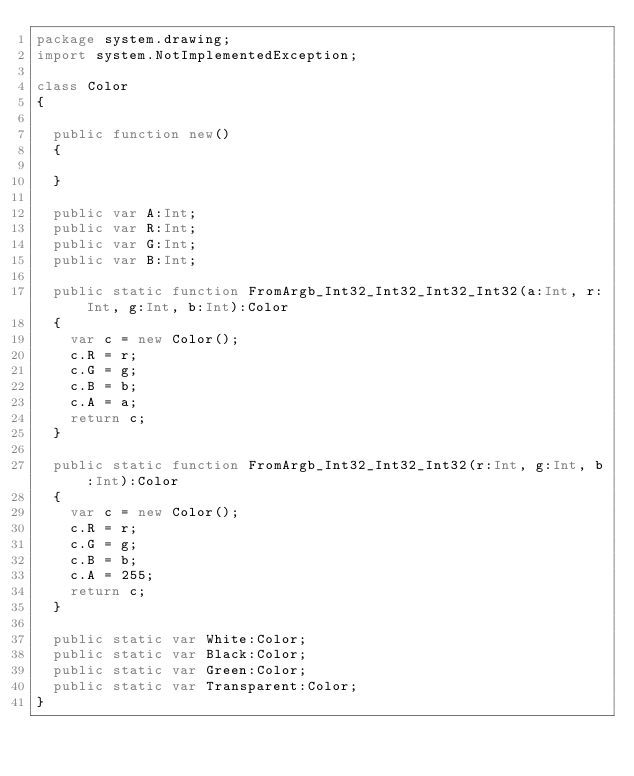<code> <loc_0><loc_0><loc_500><loc_500><_Haxe_>package system.drawing;
import system.NotImplementedException;

class Color
{

	public function new() 
	{
		
	}
	
	public var A:Int;
	public var R:Int;
	public var G:Int;
	public var B:Int;
	
	public static function FromArgb_Int32_Int32_Int32_Int32(a:Int, r:Int, g:Int, b:Int):Color
	{
		var c = new Color();
		c.R = r;
		c.G = g;
		c.B = b;
		c.A = a;
		return c;
	}
	
	public static function FromArgb_Int32_Int32_Int32(r:Int, g:Int, b:Int):Color
	{
		var c = new Color();
		c.R = r;
		c.G = g;
		c.B = b;
		c.A = 255;
		return c;
	}
	
	public static var White:Color;
	public static var Black:Color;
	public static var Green:Color;
	public static var Transparent:Color;
}</code> 